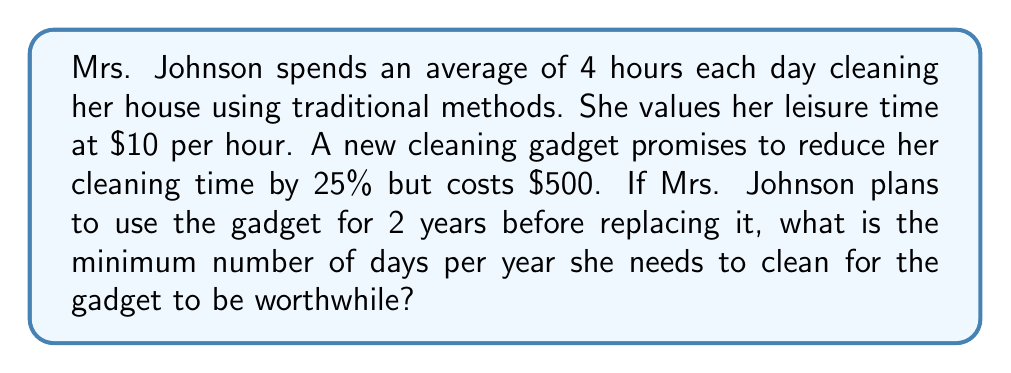Provide a solution to this math problem. Let's approach this problem step by step:

1) First, let's calculate how much time Mrs. Johnson would save per day:
   $$4 \text{ hours} \times 25\% = 1 \text{ hour}$$

2) This means she would gain 1 hour of leisure time each day she cleans.

3) The value of this leisure time is:
   $$1 \text{ hour} \times \$10/\text{hour} = \$10/\text{day}$$

4) Over 2 years, the gadget needs to save at least $500 to be worthwhile:
   $$500 = 10x \times 2$$
   Where $x$ is the number of days per year she needs to clean.

5) Solving for $x$:
   $$500 = 20x$$
   $$x = 500 \div 20 = 25$$

Therefore, Mrs. Johnson needs to clean for at least 25 days per year for the gadget to be worthwhile.
Answer: 25 days per year 